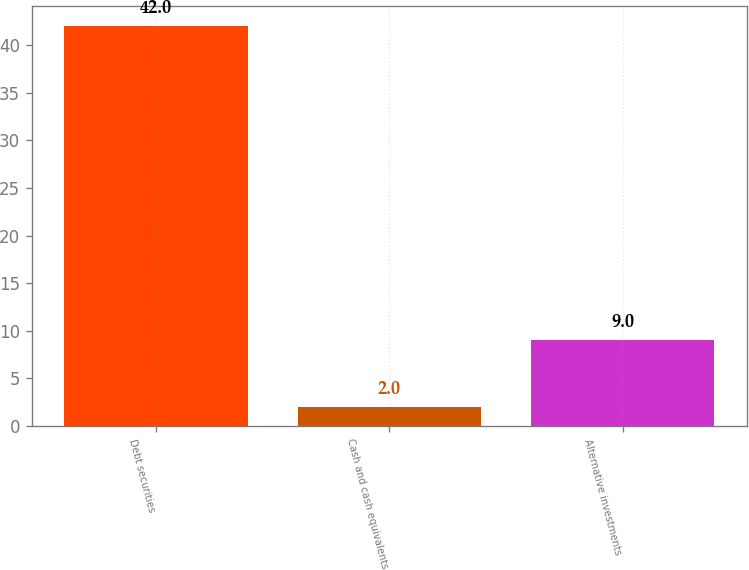Convert chart. <chart><loc_0><loc_0><loc_500><loc_500><bar_chart><fcel>Debt securities<fcel>Cash and cash equivalents<fcel>Alternative investments<nl><fcel>42<fcel>2<fcel>9<nl></chart> 